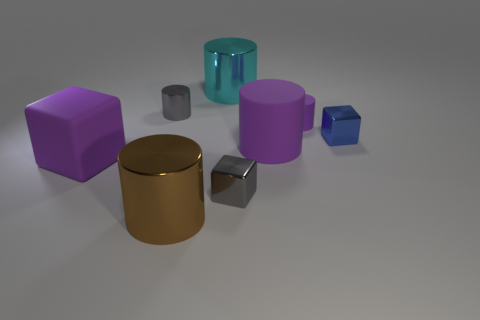Subtract all cyan cylinders. How many cylinders are left? 4 Subtract all small purple rubber cylinders. How many cylinders are left? 4 Subtract all red cylinders. Subtract all gray blocks. How many cylinders are left? 5 Add 1 large blue metal balls. How many objects exist? 9 Subtract all cubes. How many objects are left? 5 Subtract 0 cyan blocks. How many objects are left? 8 Subtract all purple cubes. Subtract all big cyan cylinders. How many objects are left? 6 Add 7 purple rubber things. How many purple rubber things are left? 10 Add 5 tiny purple matte cylinders. How many tiny purple matte cylinders exist? 6 